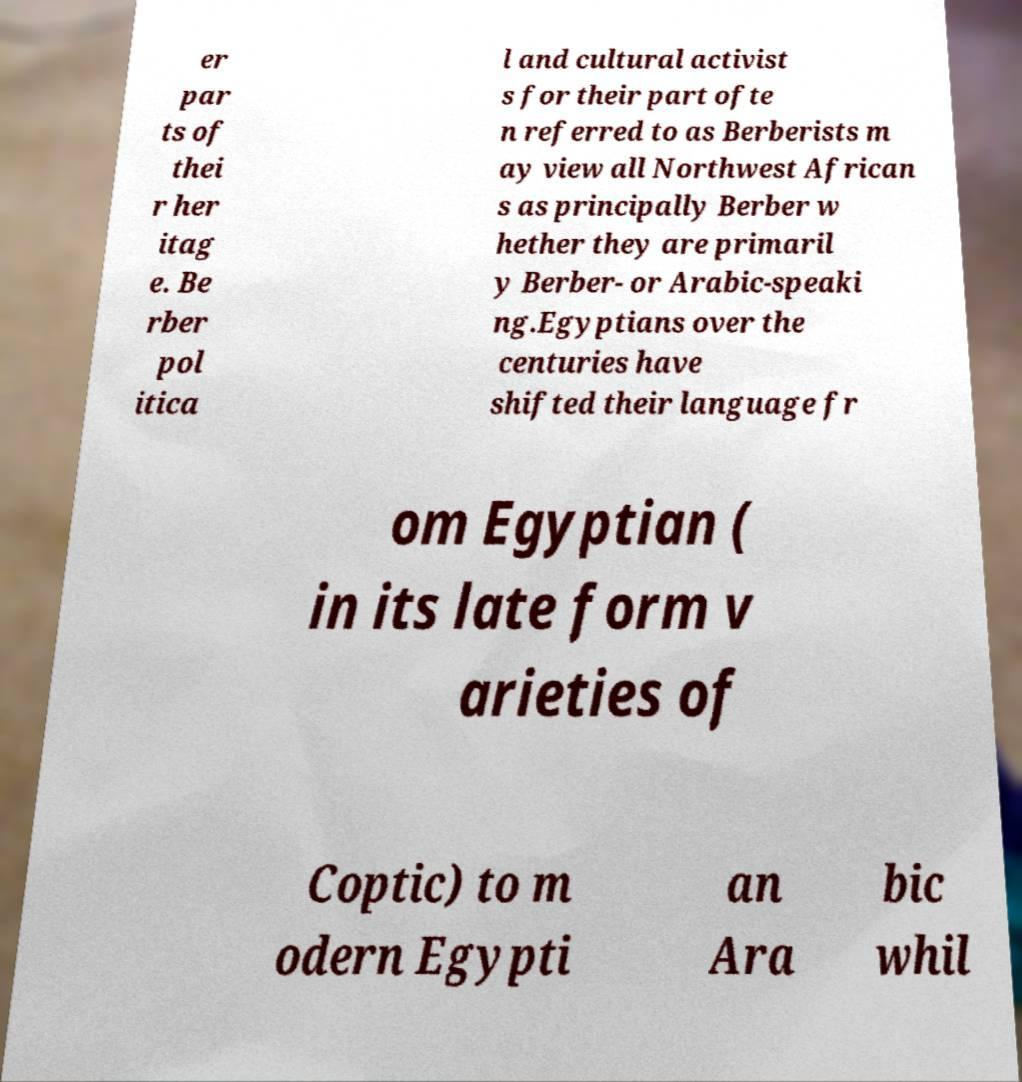Please identify and transcribe the text found in this image. er par ts of thei r her itag e. Be rber pol itica l and cultural activist s for their part ofte n referred to as Berberists m ay view all Northwest African s as principally Berber w hether they are primaril y Berber- or Arabic-speaki ng.Egyptians over the centuries have shifted their language fr om Egyptian ( in its late form v arieties of Coptic) to m odern Egypti an Ara bic whil 